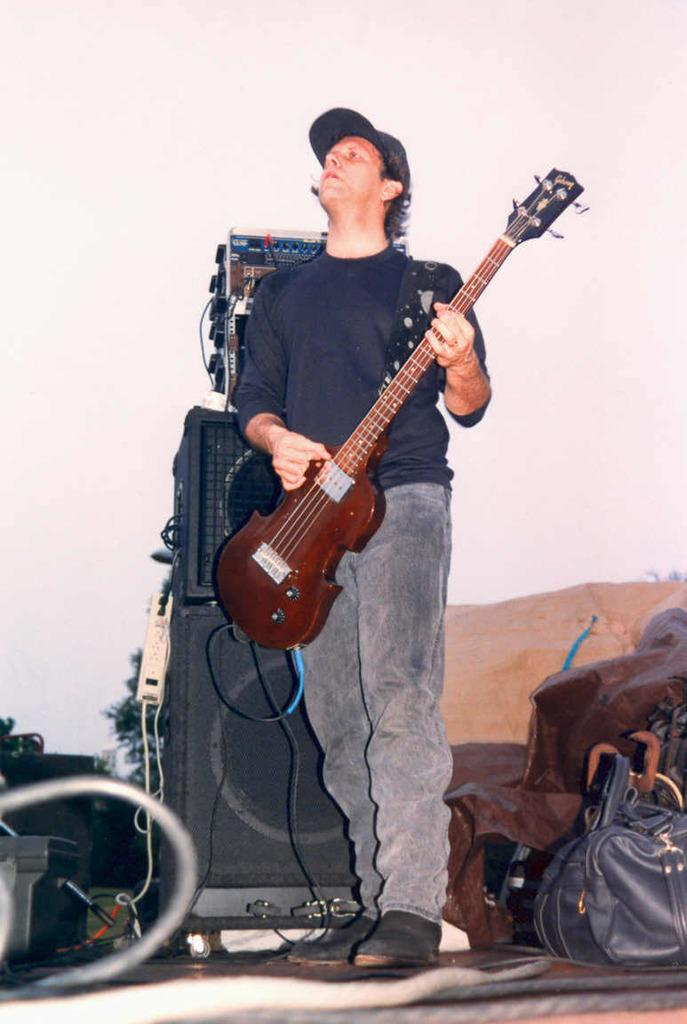What is the person in the image doing? The person in the image is playing guitar. What is located behind the person? There is a sound box behind the person. Can you identify any other objects in the image? Yes, there is a bag present in the image. What type of wood can be seen in the image? There is no wood present in the image. How many bananas are visible in the image? There are no bananas present in the image. 